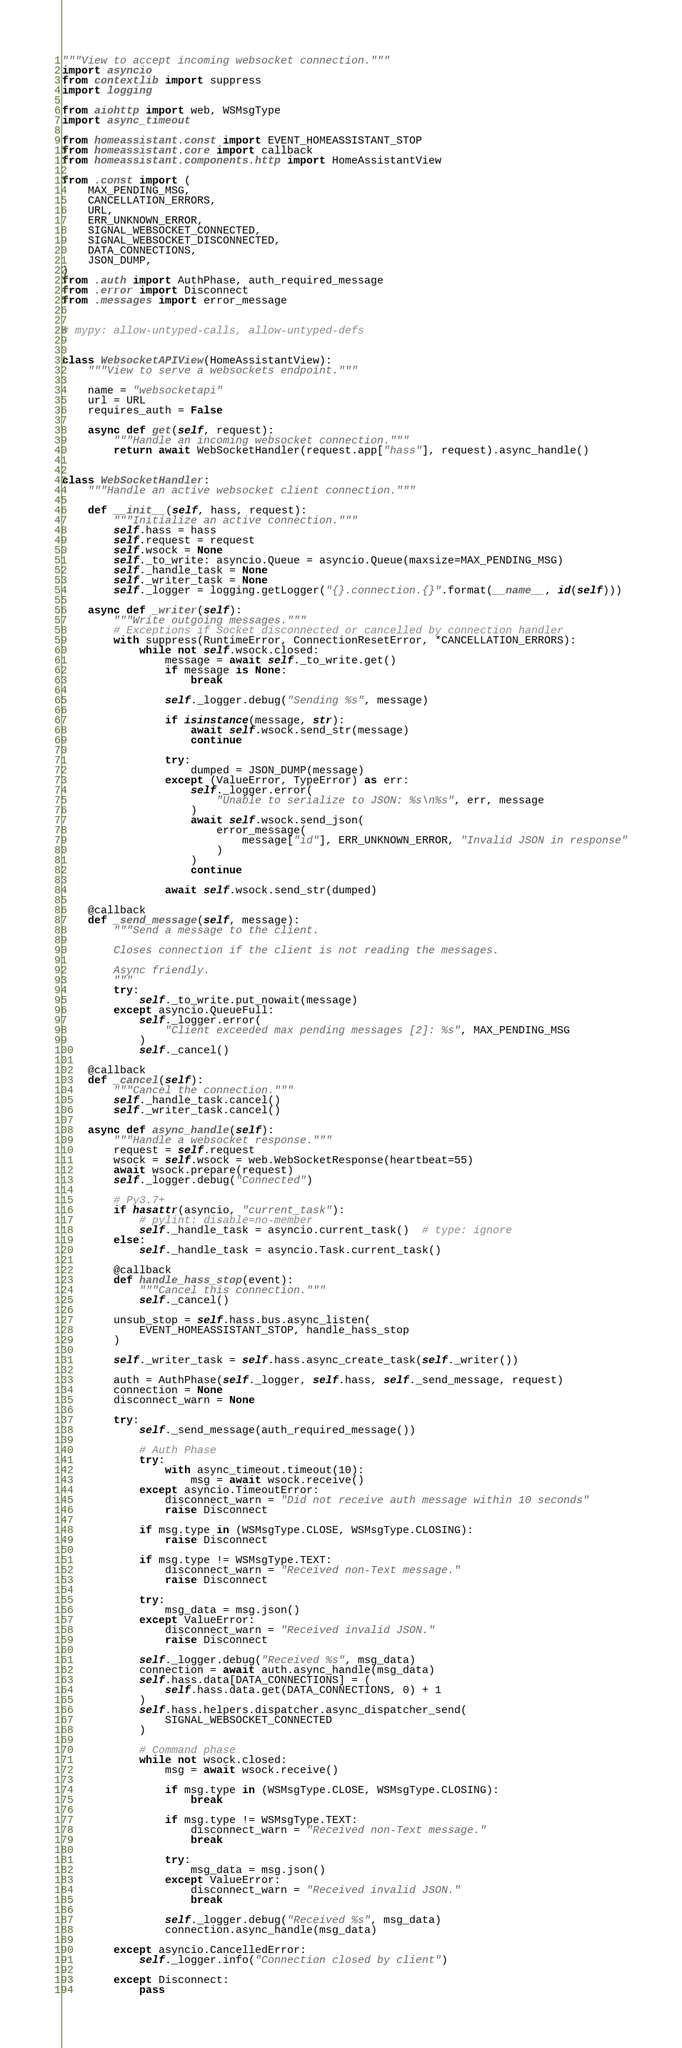<code> <loc_0><loc_0><loc_500><loc_500><_Python_>"""View to accept incoming websocket connection."""
import asyncio
from contextlib import suppress
import logging

from aiohttp import web, WSMsgType
import async_timeout

from homeassistant.const import EVENT_HOMEASSISTANT_STOP
from homeassistant.core import callback
from homeassistant.components.http import HomeAssistantView

from .const import (
    MAX_PENDING_MSG,
    CANCELLATION_ERRORS,
    URL,
    ERR_UNKNOWN_ERROR,
    SIGNAL_WEBSOCKET_CONNECTED,
    SIGNAL_WEBSOCKET_DISCONNECTED,
    DATA_CONNECTIONS,
    JSON_DUMP,
)
from .auth import AuthPhase, auth_required_message
from .error import Disconnect
from .messages import error_message


# mypy: allow-untyped-calls, allow-untyped-defs


class WebsocketAPIView(HomeAssistantView):
    """View to serve a websockets endpoint."""

    name = "websocketapi"
    url = URL
    requires_auth = False

    async def get(self, request):
        """Handle an incoming websocket connection."""
        return await WebSocketHandler(request.app["hass"], request).async_handle()


class WebSocketHandler:
    """Handle an active websocket client connection."""

    def __init__(self, hass, request):
        """Initialize an active connection."""
        self.hass = hass
        self.request = request
        self.wsock = None
        self._to_write: asyncio.Queue = asyncio.Queue(maxsize=MAX_PENDING_MSG)
        self._handle_task = None
        self._writer_task = None
        self._logger = logging.getLogger("{}.connection.{}".format(__name__, id(self)))

    async def _writer(self):
        """Write outgoing messages."""
        # Exceptions if Socket disconnected or cancelled by connection handler
        with suppress(RuntimeError, ConnectionResetError, *CANCELLATION_ERRORS):
            while not self.wsock.closed:
                message = await self._to_write.get()
                if message is None:
                    break

                self._logger.debug("Sending %s", message)

                if isinstance(message, str):
                    await self.wsock.send_str(message)
                    continue

                try:
                    dumped = JSON_DUMP(message)
                except (ValueError, TypeError) as err:
                    self._logger.error(
                        "Unable to serialize to JSON: %s\n%s", err, message
                    )
                    await self.wsock.send_json(
                        error_message(
                            message["id"], ERR_UNKNOWN_ERROR, "Invalid JSON in response"
                        )
                    )
                    continue

                await self.wsock.send_str(dumped)

    @callback
    def _send_message(self, message):
        """Send a message to the client.

        Closes connection if the client is not reading the messages.

        Async friendly.
        """
        try:
            self._to_write.put_nowait(message)
        except asyncio.QueueFull:
            self._logger.error(
                "Client exceeded max pending messages [2]: %s", MAX_PENDING_MSG
            )
            self._cancel()

    @callback
    def _cancel(self):
        """Cancel the connection."""
        self._handle_task.cancel()
        self._writer_task.cancel()

    async def async_handle(self):
        """Handle a websocket response."""
        request = self.request
        wsock = self.wsock = web.WebSocketResponse(heartbeat=55)
        await wsock.prepare(request)
        self._logger.debug("Connected")

        # Py3.7+
        if hasattr(asyncio, "current_task"):
            # pylint: disable=no-member
            self._handle_task = asyncio.current_task()  # type: ignore
        else:
            self._handle_task = asyncio.Task.current_task()

        @callback
        def handle_hass_stop(event):
            """Cancel this connection."""
            self._cancel()

        unsub_stop = self.hass.bus.async_listen(
            EVENT_HOMEASSISTANT_STOP, handle_hass_stop
        )

        self._writer_task = self.hass.async_create_task(self._writer())

        auth = AuthPhase(self._logger, self.hass, self._send_message, request)
        connection = None
        disconnect_warn = None

        try:
            self._send_message(auth_required_message())

            # Auth Phase
            try:
                with async_timeout.timeout(10):
                    msg = await wsock.receive()
            except asyncio.TimeoutError:
                disconnect_warn = "Did not receive auth message within 10 seconds"
                raise Disconnect

            if msg.type in (WSMsgType.CLOSE, WSMsgType.CLOSING):
                raise Disconnect

            if msg.type != WSMsgType.TEXT:
                disconnect_warn = "Received non-Text message."
                raise Disconnect

            try:
                msg_data = msg.json()
            except ValueError:
                disconnect_warn = "Received invalid JSON."
                raise Disconnect

            self._logger.debug("Received %s", msg_data)
            connection = await auth.async_handle(msg_data)
            self.hass.data[DATA_CONNECTIONS] = (
                self.hass.data.get(DATA_CONNECTIONS, 0) + 1
            )
            self.hass.helpers.dispatcher.async_dispatcher_send(
                SIGNAL_WEBSOCKET_CONNECTED
            )

            # Command phase
            while not wsock.closed:
                msg = await wsock.receive()

                if msg.type in (WSMsgType.CLOSE, WSMsgType.CLOSING):
                    break

                if msg.type != WSMsgType.TEXT:
                    disconnect_warn = "Received non-Text message."
                    break

                try:
                    msg_data = msg.json()
                except ValueError:
                    disconnect_warn = "Received invalid JSON."
                    break

                self._logger.debug("Received %s", msg_data)
                connection.async_handle(msg_data)

        except asyncio.CancelledError:
            self._logger.info("Connection closed by client")

        except Disconnect:
            pass
</code> 